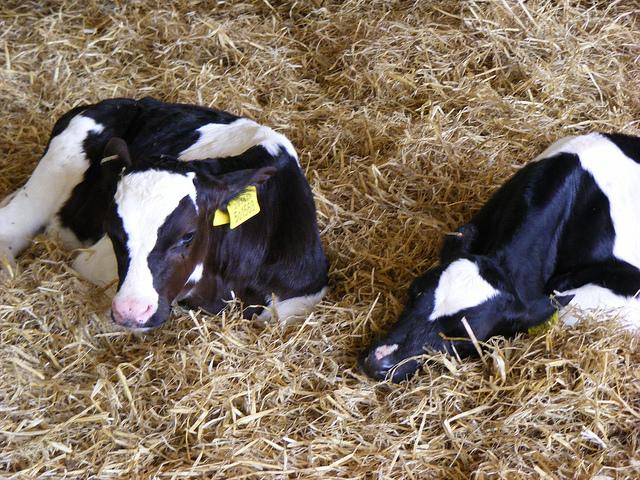Will these animals try to eat each other?
Concise answer only. No. Are these animals old or newer?
Keep it brief. Newer. What color is the cow's tag?
Concise answer only. Yellow. 